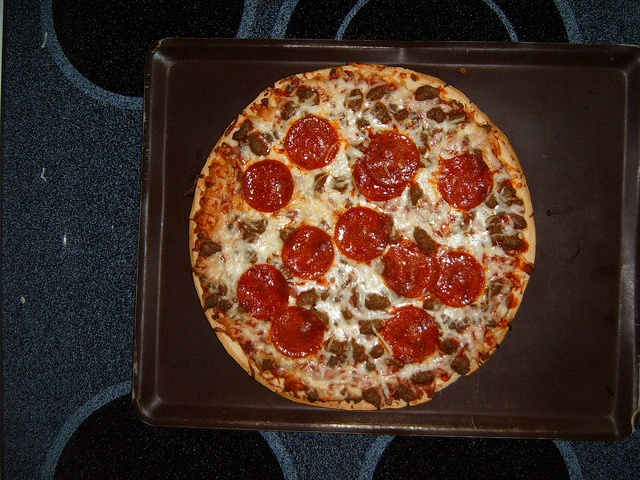Describe the objects in this image and their specific colors. I can see oven in gray, black, and darkblue tones and pizza in gray, maroon, brown, and tan tones in this image. 